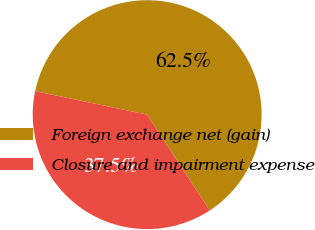<chart> <loc_0><loc_0><loc_500><loc_500><pie_chart><fcel>Foreign exchange net (gain)<fcel>Closure and impairment expense<nl><fcel>62.5%<fcel>37.5%<nl></chart> 